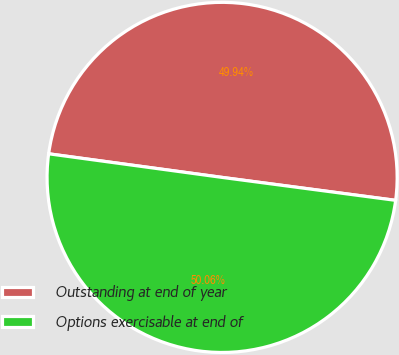Convert chart to OTSL. <chart><loc_0><loc_0><loc_500><loc_500><pie_chart><fcel>Outstanding at end of year<fcel>Options exercisable at end of<nl><fcel>49.94%<fcel>50.06%<nl></chart> 